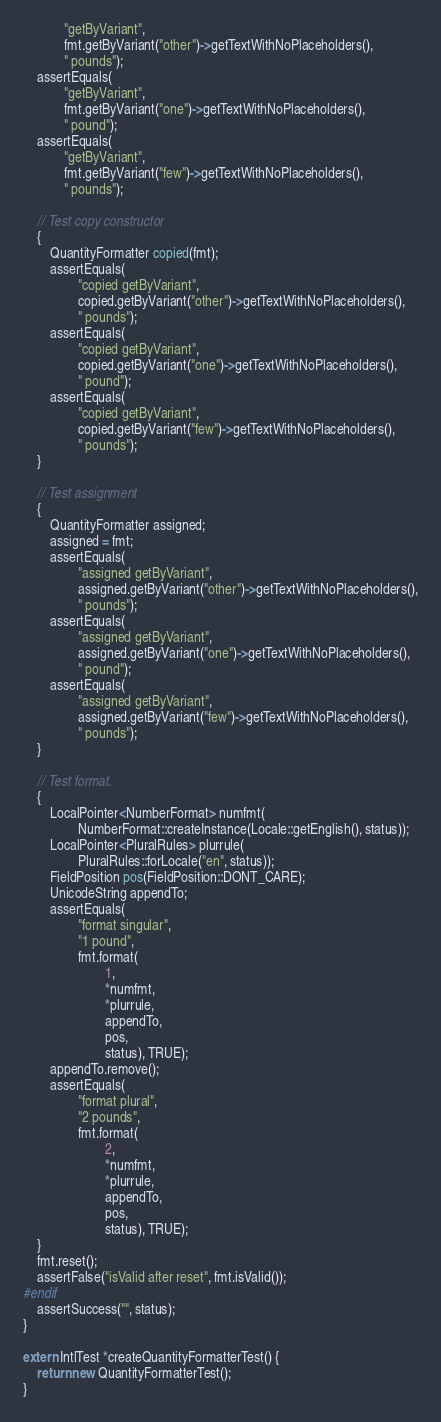<code> <loc_0><loc_0><loc_500><loc_500><_C++_>            "getByVariant",
            fmt.getByVariant("other")->getTextWithNoPlaceholders(),
            " pounds");
    assertEquals(
            "getByVariant",
            fmt.getByVariant("one")->getTextWithNoPlaceholders(),
            " pound");
    assertEquals(
            "getByVariant",
            fmt.getByVariant("few")->getTextWithNoPlaceholders(),
            " pounds");

    // Test copy constructor
    {
        QuantityFormatter copied(fmt);
        assertEquals(
                "copied getByVariant",
                copied.getByVariant("other")->getTextWithNoPlaceholders(),
                " pounds");
        assertEquals(
                "copied getByVariant",
                copied.getByVariant("one")->getTextWithNoPlaceholders(),
                " pound");
        assertEquals(
                "copied getByVariant",
                copied.getByVariant("few")->getTextWithNoPlaceholders(),
                " pounds");
    }
        
    // Test assignment
    {
        QuantityFormatter assigned;
        assigned = fmt;
        assertEquals(
                "assigned getByVariant",
                assigned.getByVariant("other")->getTextWithNoPlaceholders(),
                " pounds");
        assertEquals(
                "assigned getByVariant",
                assigned.getByVariant("one")->getTextWithNoPlaceholders(),
                " pound");
        assertEquals(
                "assigned getByVariant",
                assigned.getByVariant("few")->getTextWithNoPlaceholders(),
                " pounds");
    }

    // Test format.
    {
        LocalPointer<NumberFormat> numfmt(
                NumberFormat::createInstance(Locale::getEnglish(), status));
        LocalPointer<PluralRules> plurrule(
                PluralRules::forLocale("en", status));
        FieldPosition pos(FieldPosition::DONT_CARE);
        UnicodeString appendTo;
        assertEquals(
                "format singular",
                "1 pound",
                fmt.format(
                        1,
                        *numfmt,
                        *plurrule,
                        appendTo,
                        pos,
                        status), TRUE);
        appendTo.remove();
        assertEquals(
                "format plural",
                "2 pounds",
                fmt.format(
                        2,
                        *numfmt,
                        *plurrule,
                        appendTo,
                        pos,
                        status), TRUE);
    }
    fmt.reset();
    assertFalse("isValid after reset", fmt.isValid());
#endif
    assertSuccess("", status);
}

extern IntlTest *createQuantityFormatterTest() {
    return new QuantityFormatterTest();
}
</code> 